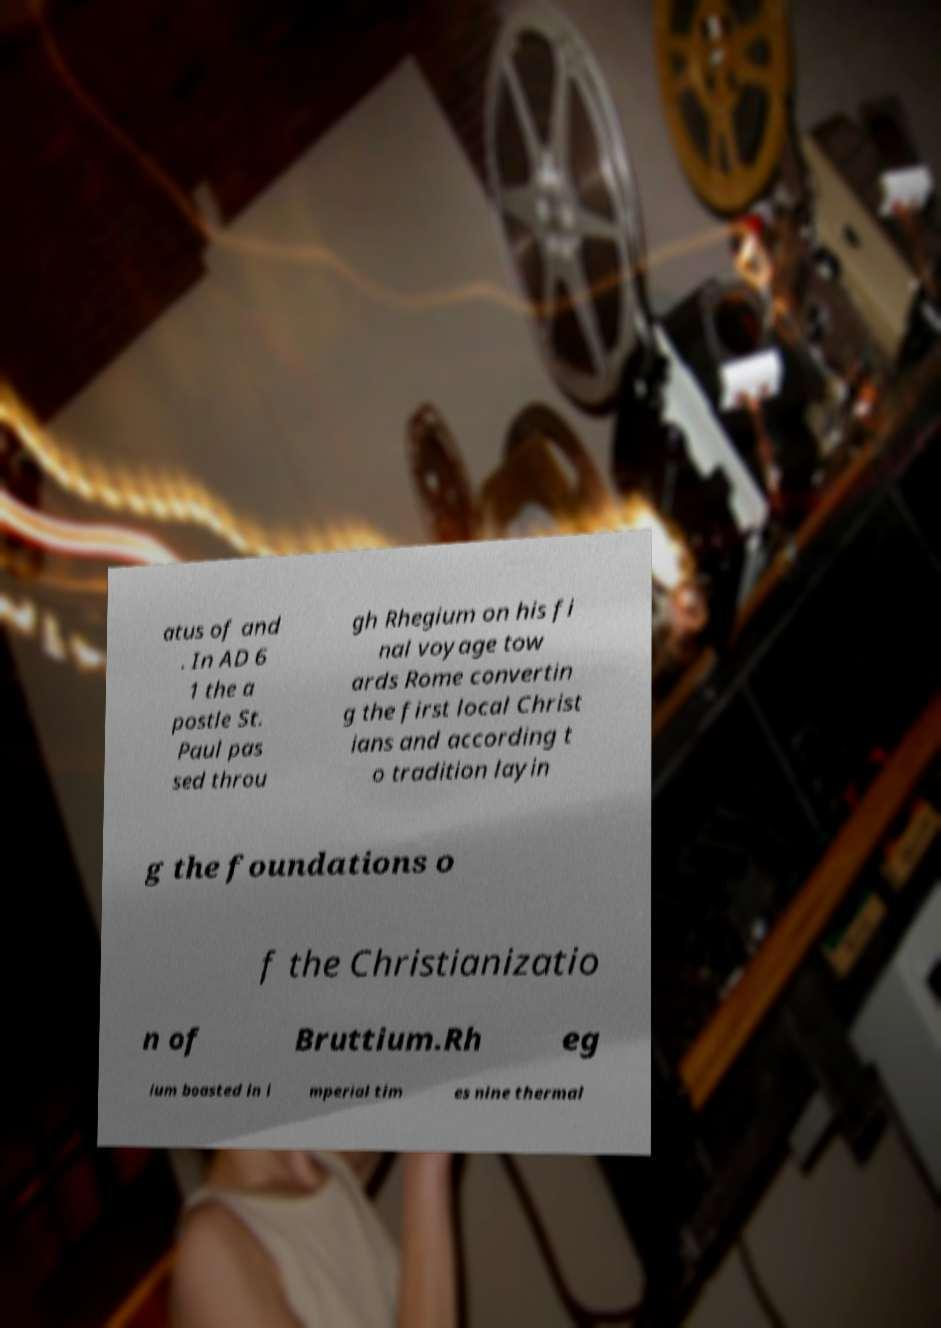Can you accurately transcribe the text from the provided image for me? atus of and . In AD 6 1 the a postle St. Paul pas sed throu gh Rhegium on his fi nal voyage tow ards Rome convertin g the first local Christ ians and according t o tradition layin g the foundations o f the Christianizatio n of Bruttium.Rh eg ium boasted in i mperial tim es nine thermal 